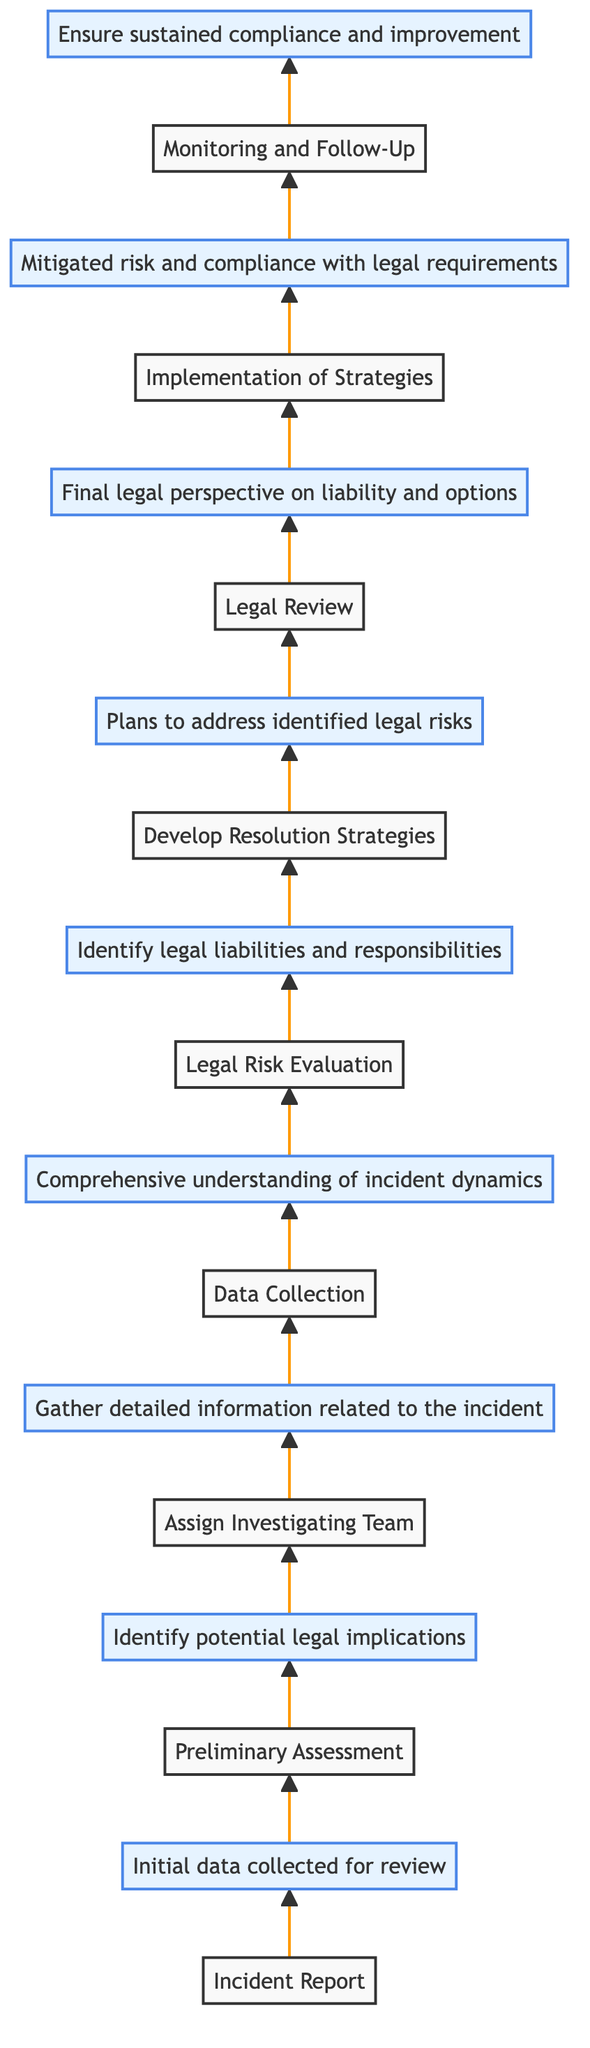What is the first action taken in the incident investigation flow? The first action is "Receive incident report from employee or external party," which is clearly stated as the starting node in the diagram.
Answer: Receive incident report from employee or external party What is the outcome of the Legal Review action? The outcome associated with the Legal Review action is "Final legal perspective on liability and options," which is directly connected from the Legal Review node in the diagram.
Answer: Final legal perspective on liability and options How many distinct actions are included in the flow chart? By counting the individual action nodes listed in the diagram, there are a total of eight distinct actions that occur throughout the incident investigation flow.
Answer: Eight What comes after the Data Collection in the flow? Following the Data Collection action, the next action in the flow is "Consult with legal experts to assess risks," which is indicated by the directional arrow leading from Data Collection to Legal Risk Evaluation in the diagram.
Answer: Consult with legal experts to assess risks What is the last action in the incident investigation flow? The final action in the flow is "Monitor outcomes and follow up on implementation," represented as the last node in the sequence, indicating the conclusion of the investigation process.
Answer: Monitor outcomes and follow up on implementation What is the relationship between the Preliminary Assessment and the Assign Investigating Team nodes? The Preliminary Assessment directly leads to the Assign Investigating Team action, meaning the outcomes of the assessment inform the decision to assign the investigation team, as shown by the directed edge connecting these nodes.
Answer: Directly leads to What action directly follows the Legal Risk Evaluation? The action that comes directly after the Legal Risk Evaluation is "Develop strategies for incident resolution and risk mitigation," which follows in the sequence of actions as portrayed in the flow chart.
Answer: Develop strategies for incident resolution and risk mitigation How many outcomes are there in total in this flow chart? There are eight distinct outcomes listed corresponding to each action in the flow chart, which are visually represented alongside their respective action nodes.
Answer: Eight What is a key purpose of the Implementation of Strategies action? The key purpose of the Implementation of Strategies action is to ensure "Mitigated risk and compliance with legal requirements," as specified in the outcome connected to that action in the diagram.
Answer: Mitigated risk and compliance with legal requirements 